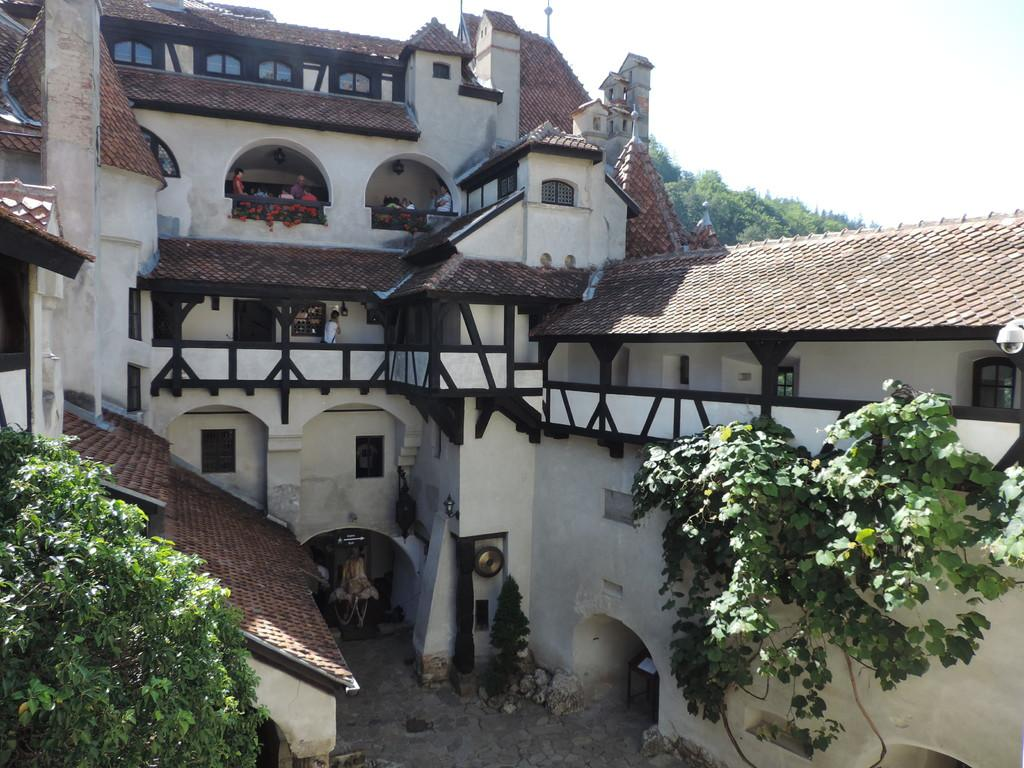What type of structures can be seen in the image? There are buildings in the image. What type of vegetation is present in the image? Creepers and trees are visible in the image. What type of natural elements can be seen in the image? Stones are in the image. What are the people in the image doing? People are standing in a balcony. What is visible in the background of the image? The sky is visible in the image. What type of lace can be seen hanging from the balcony in the image? There is no lace present in the image; only people are visible in the balcony. What type of cord is used to support the creepers in the image? There is no cord visible in the image; the creepers are growing on the buildings and trees. 